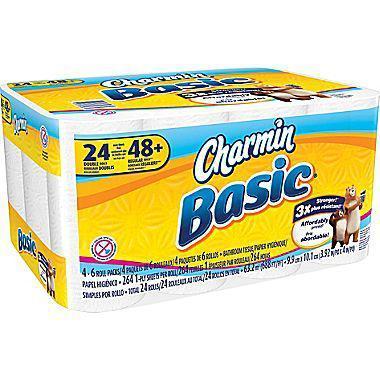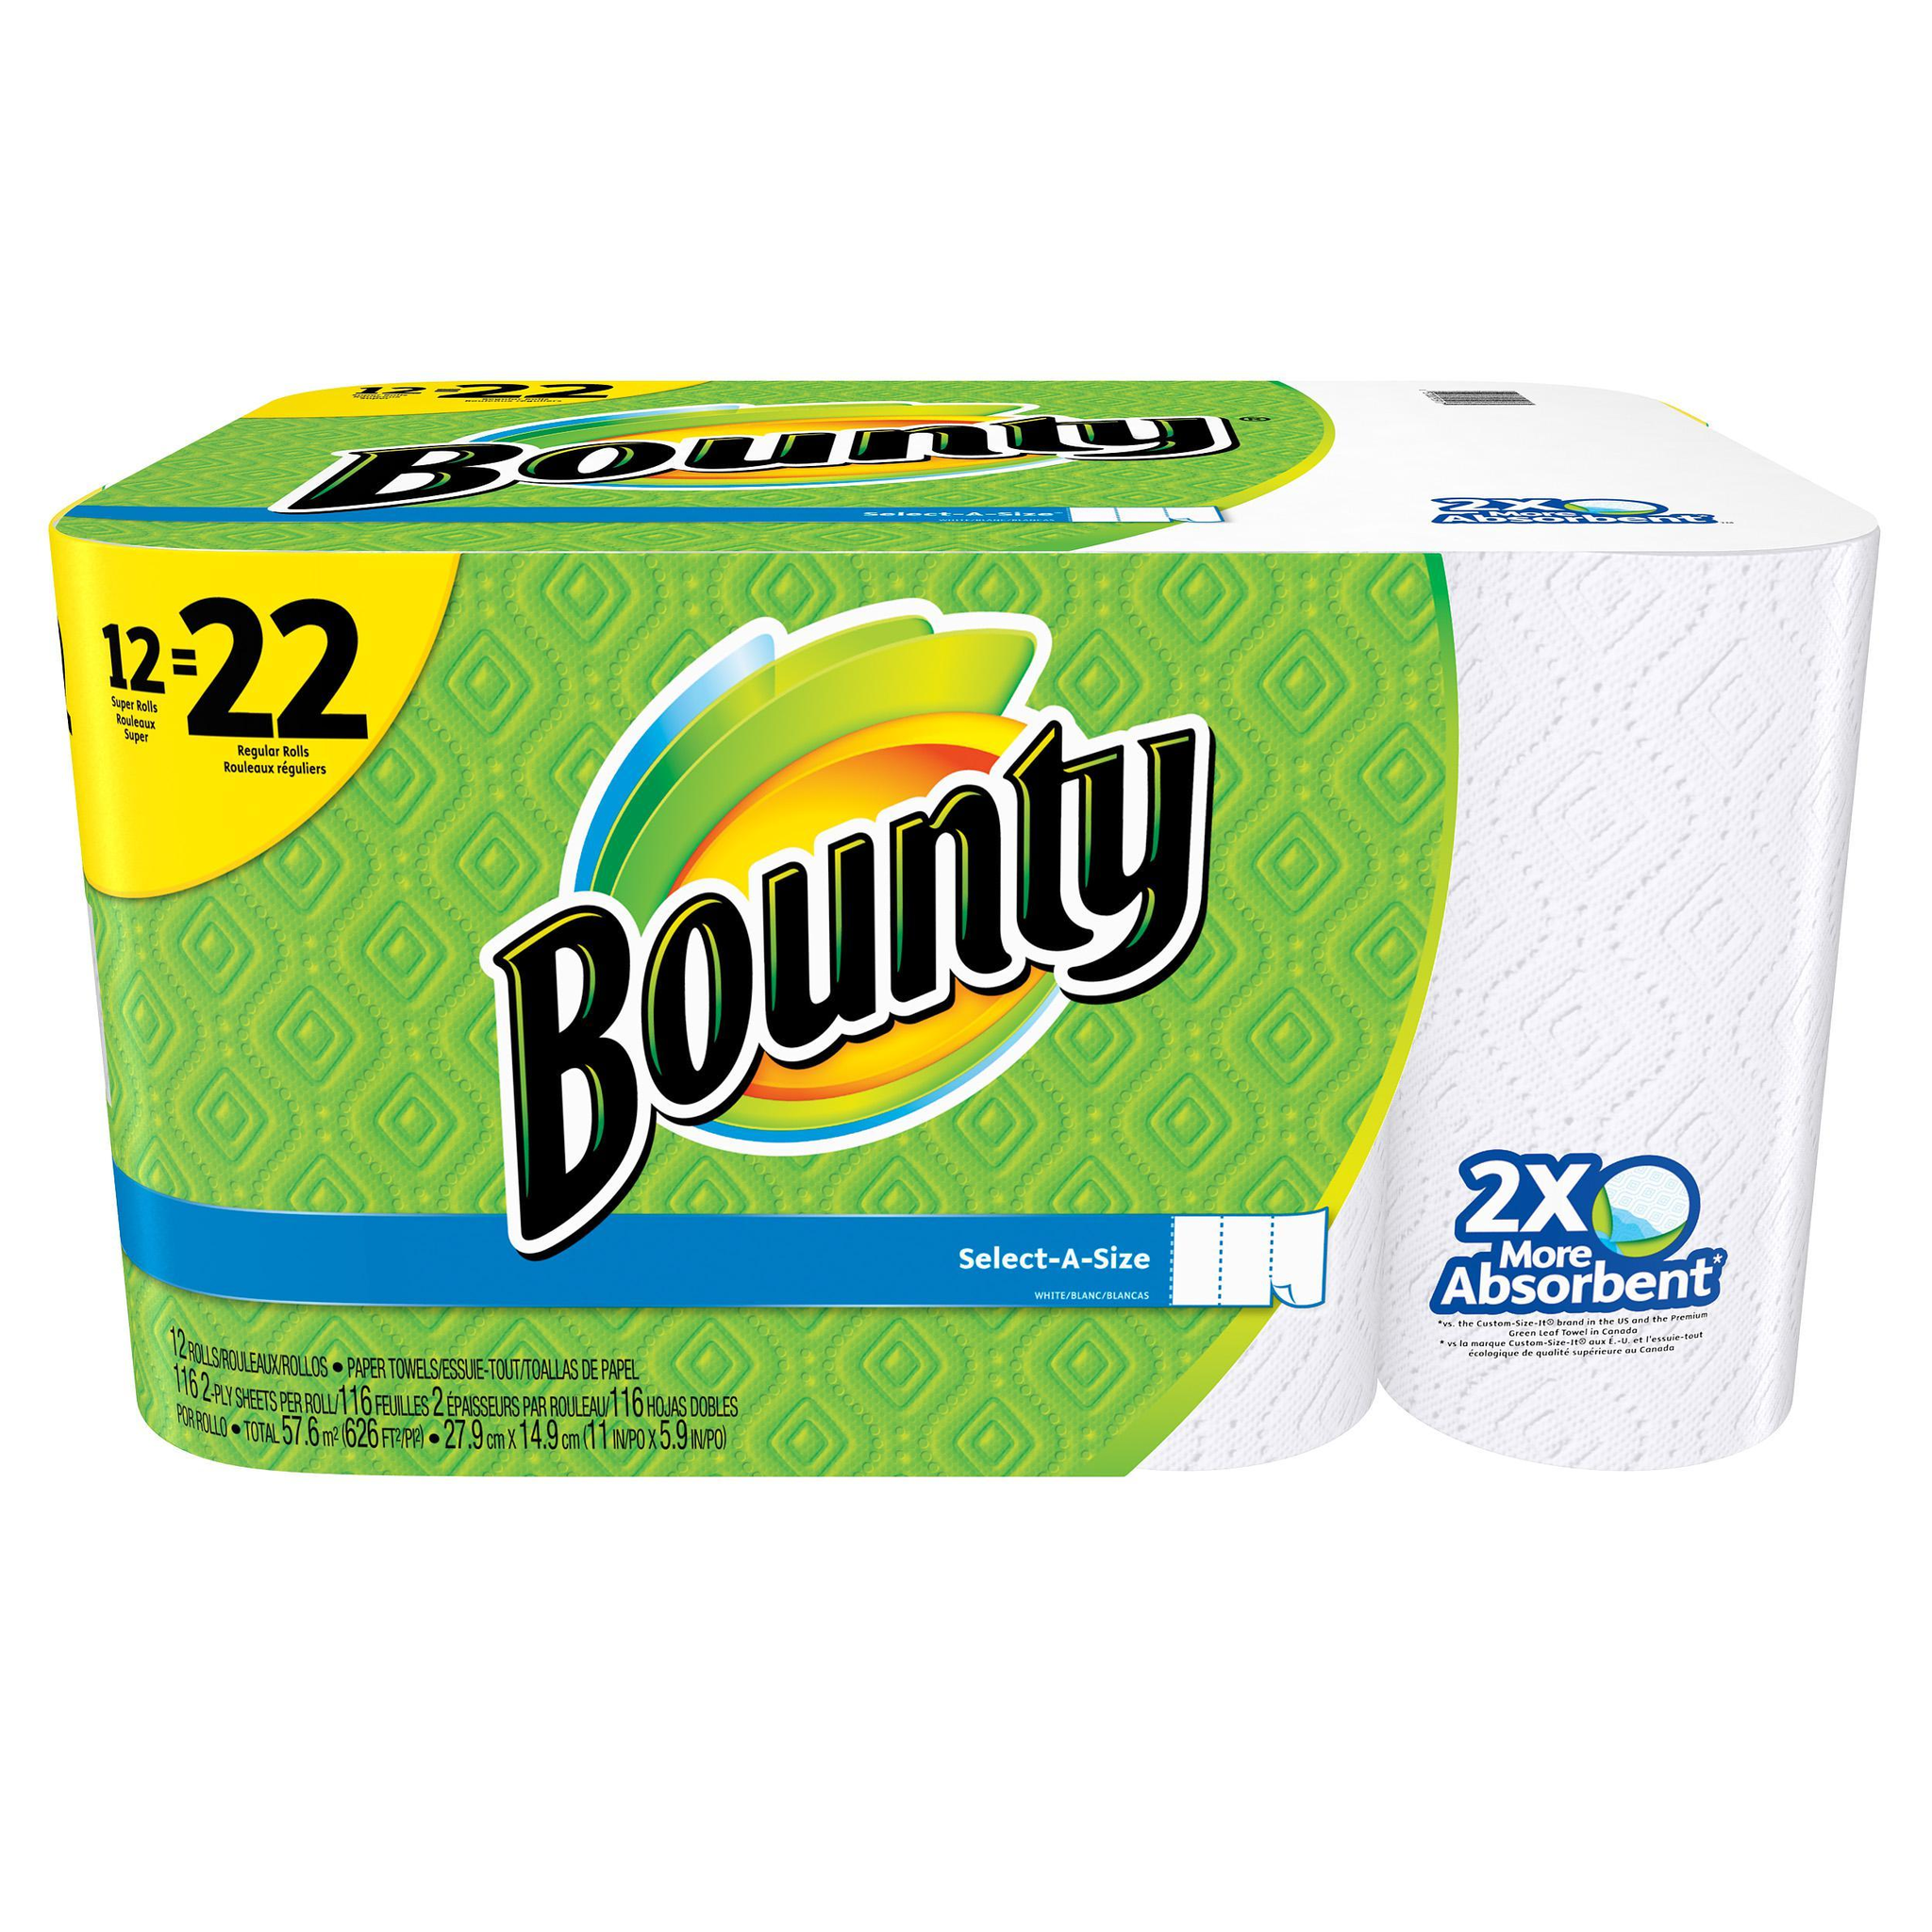The first image is the image on the left, the second image is the image on the right. Analyze the images presented: Is the assertion "The color scheme on the paper towel products on the left and right is primarily green, and each image contains exactly one multipack of paper towels." valid? Answer yes or no. No. The first image is the image on the left, the second image is the image on the right. Analyze the images presented: Is the assertion "There are more than thirteen rolls." valid? Answer yes or no. Yes. 